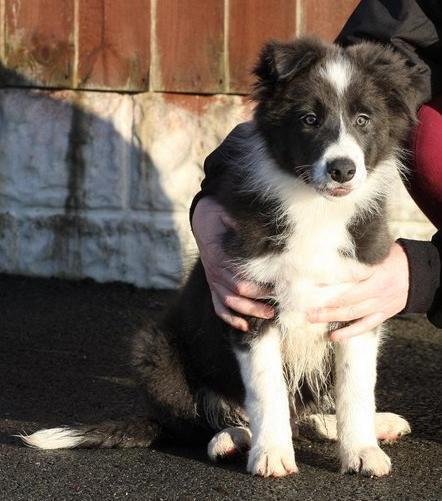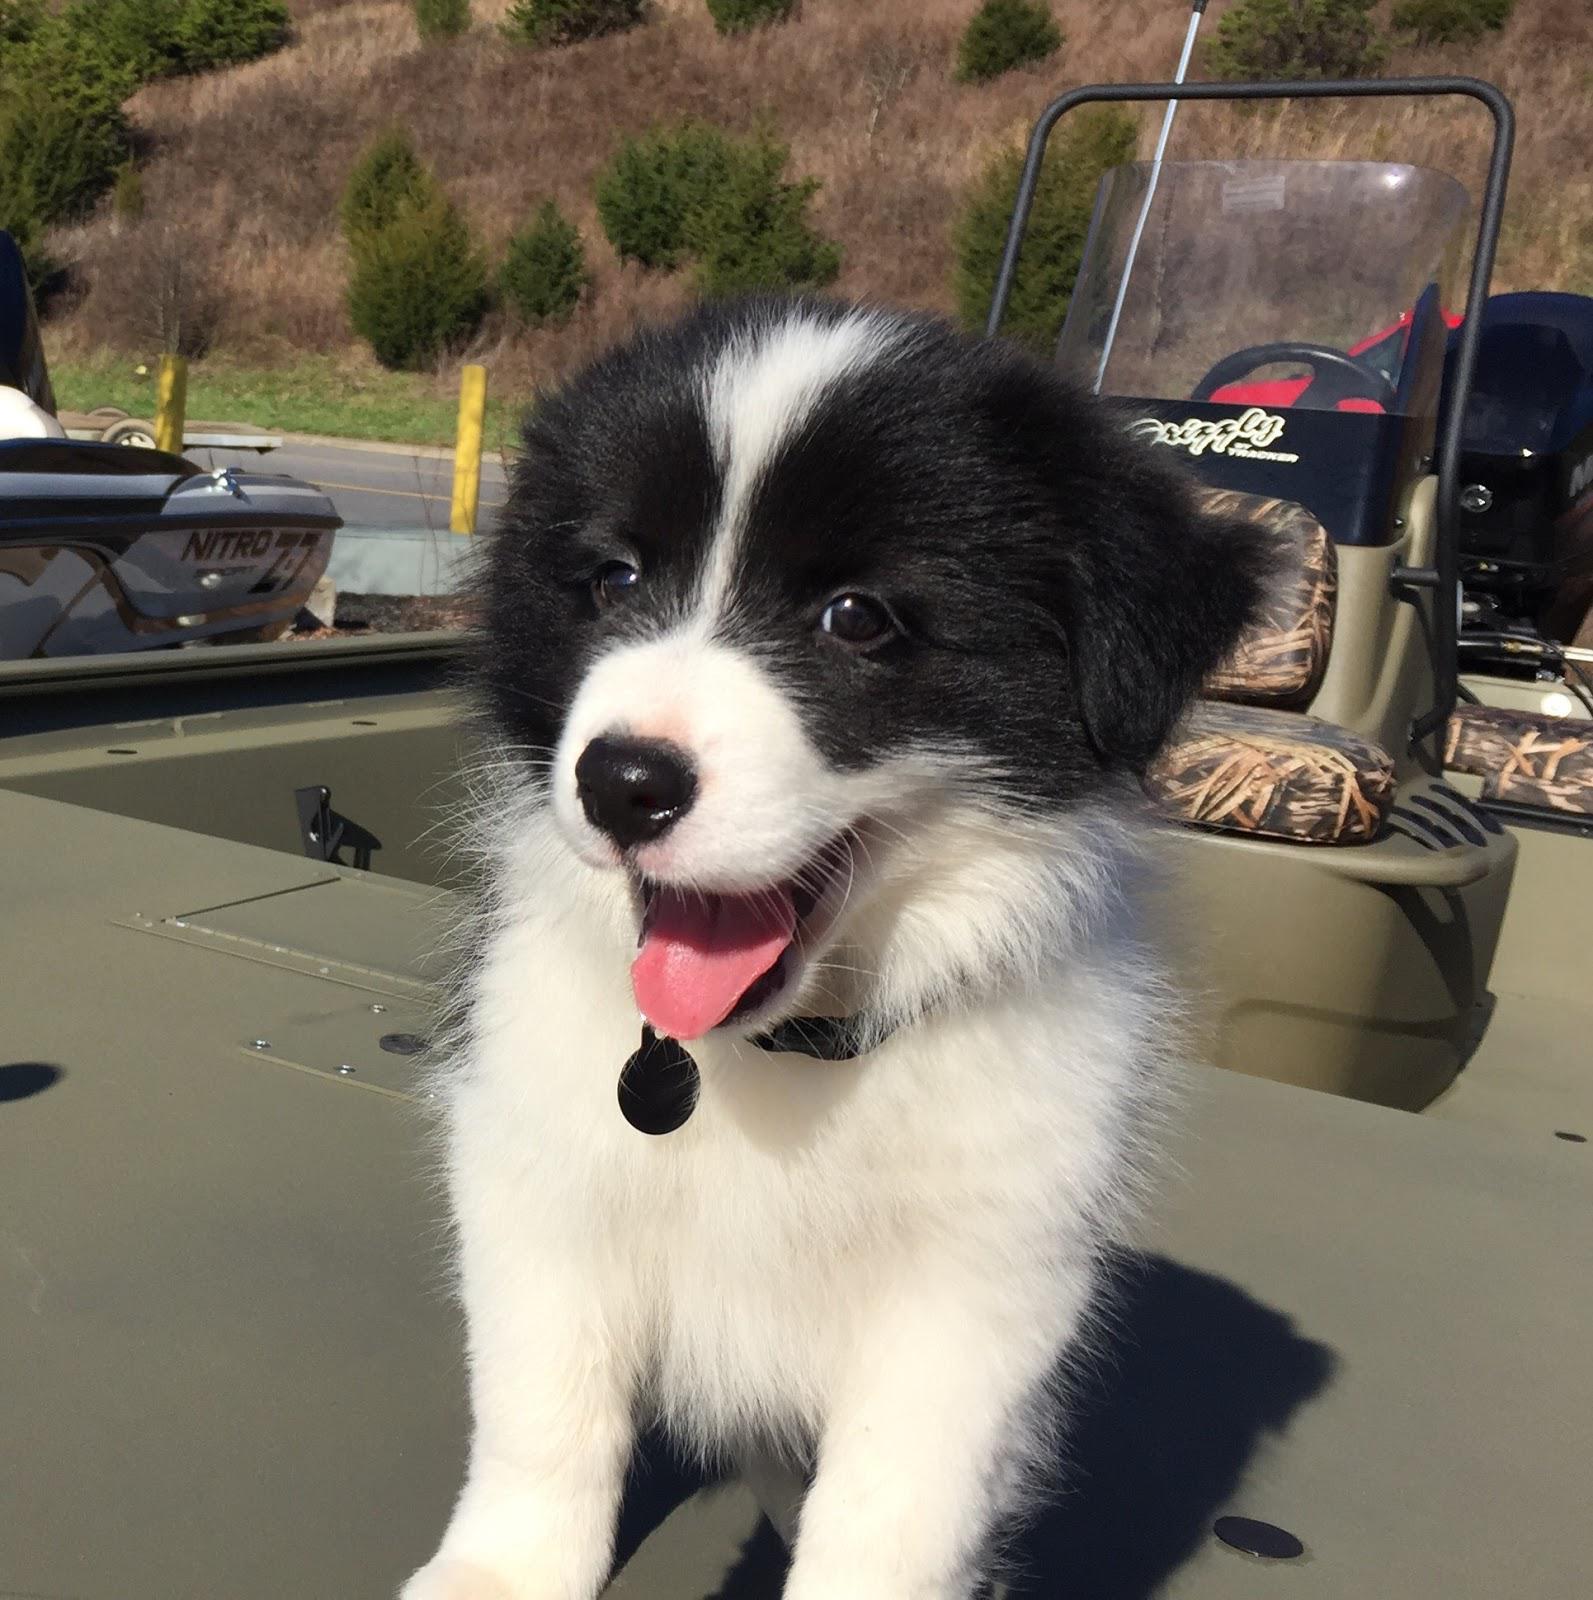The first image is the image on the left, the second image is the image on the right. Assess this claim about the two images: "a dog is looking at the cameral with a brick wall behind it". Correct or not? Answer yes or no. Yes. The first image is the image on the left, the second image is the image on the right. Assess this claim about the two images: "A black and white dog with black spots is standing on the ground outside.". Correct or not? Answer yes or no. No. 